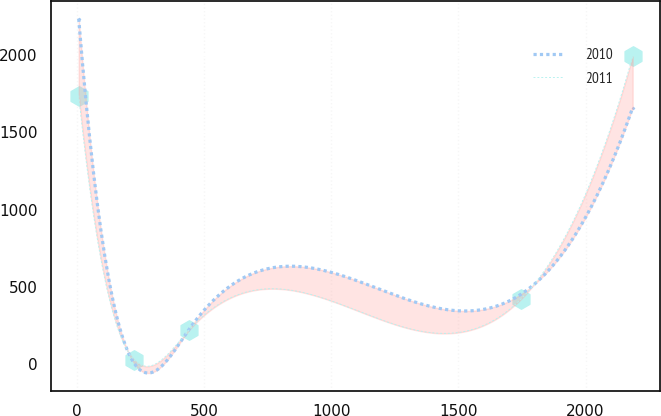Convert chart. <chart><loc_0><loc_0><loc_500><loc_500><line_chart><ecel><fcel>2010<fcel>2011<nl><fcel>7.96<fcel>2236.01<fcel>1739.09<nl><fcel>225.65<fcel>6.77<fcel>28.36<nl><fcel>443.34<fcel>229.69<fcel>224.68<nl><fcel>1745.57<fcel>452.61<fcel>421<nl><fcel>2184.88<fcel>1661.01<fcel>1991.59<nl></chart> 